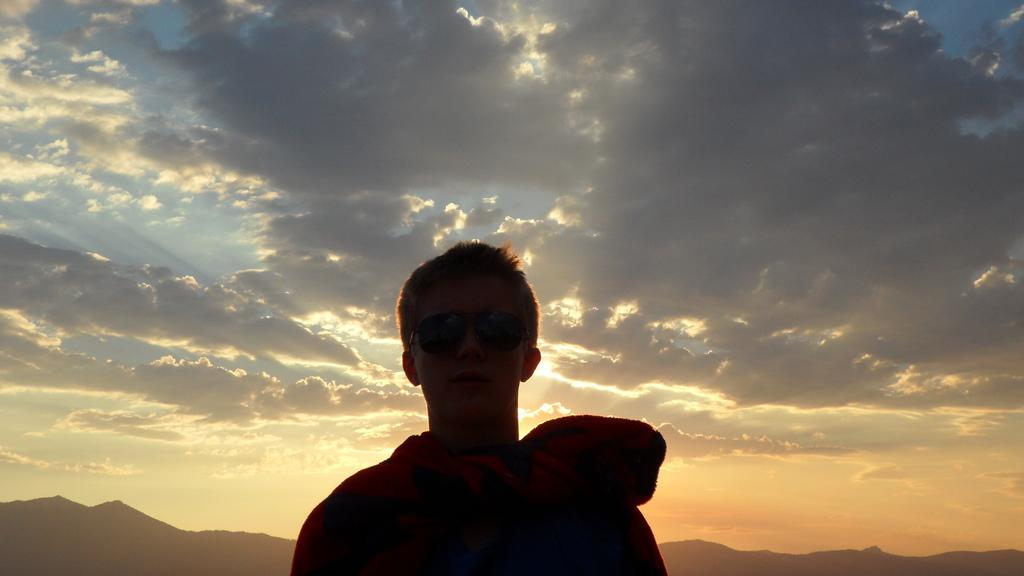What is the setting of the image? The image is an outside view. Who or what can be seen at the bottom of the image? There is a person wearing goggles at the bottom of the image. What type of landscape can be seen in the background of the image? There are hills visible in the background of the image. What is visible at the top of the image? The sky is visible at the top of the image. What can be observed in the sky? Clouds are present in the sky. What type of vest is the person wearing in the image? There is no vest visible in the image; the person is wearing goggles. What kind of apparatus is being used by the person in the image? There is no apparatus visible in the image; the person is simply wearing goggles. 